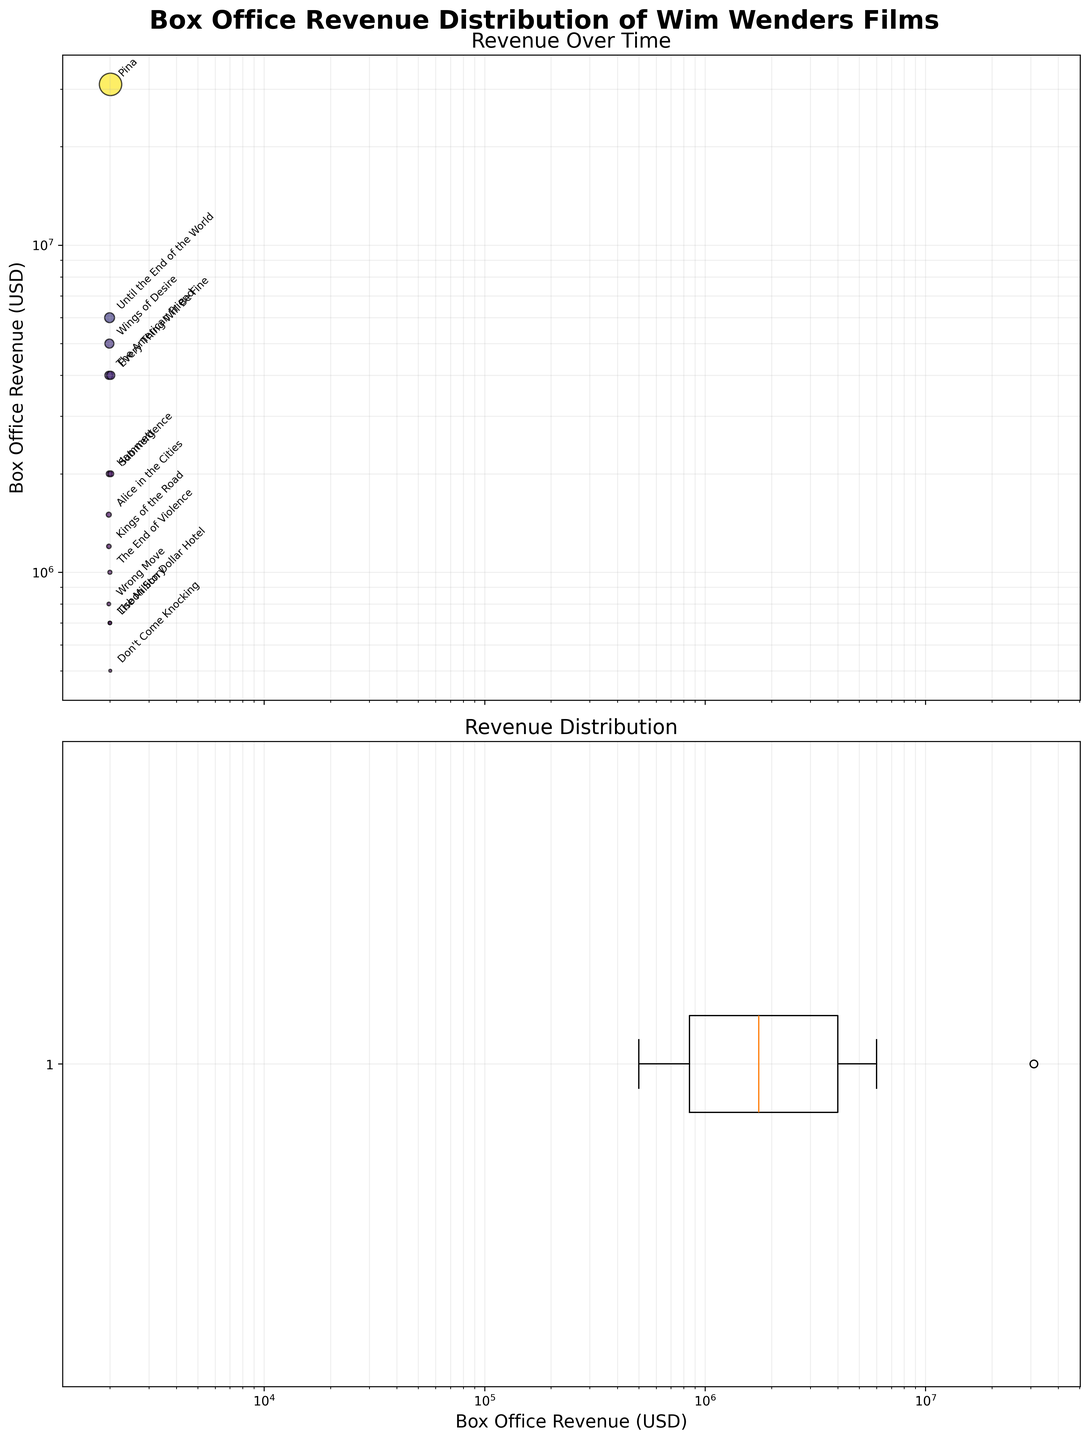What is the title of the first subplot? The title of the first subplot can be found above the plot area. It is usually a short text that summarizes what the subplot represents.
Answer: Revenue Over Time How many films are included in the dataset? By counting the number of data points (or scatter points) visible in the first subplot, we can determine the number of films. Additionally, each data point represents a different film, and their names are annotated on the plot.
Answer: 14 Which film has the highest box office revenue? The film with the highest box office revenue can be identified in the scatter plot where the y-axis value is at its maximum. Here, "Pina" stands out at the top of the plot. Moreover, the log scale on the y-axis helps visualize it clearly.
Answer: Pina What is the approximate box office revenue range covered in the dataset? Since the y-axis of the first subplot and x-axis of the second are in log scale, we should look at the minimum and maximum values on these axes. The revenues range approximately from ~500,000 to ~31,000,000 USD.
Answer: ~500,000 to ~31,000,000 USD How do the revenues of "The American Friend" and "Every Thing Will Be Fine" compare? Locate "The American Friend" and "Every Thing Will Be Fine" in the first subplot by identifying their respective points and comparing their y-axis values. "The American Friend" is around 4,000,000 USD, while "Every Thing Will Be Fine" is the same.
Answer: They are equal at 4,000,000 USD In which year did Wim Wenders release the film "Kings of the Road"? Find the annotation for "Kings of the Road" and then look at its corresponding x-axis value in the first subplot, which shows the release year.
Answer: 1976 Which film had the least box office revenue and what is that value? In the first subplot, identify the film at the lowermost point of the y-axis. Additionally, in the second subplot, the minimum value in the boxplot represents this revenue. The annotation for "Don't Come Knocking" refers to this film.
Answer: Don't Come Knocking at 500,000 USD How many films had a box office revenue of over 10 million USD? To find this, look at the scatter points in the first subplot that are above the 10 million USD mark on the log scale y-axis. Only Pina fits this criterion.
Answer: 1 film What is the median box office revenue of the films? The median value is represented by the horizontal line within the box in the second subplot. This value is located in the middle of the box representing the distribution.
Answer: Around 1,500,000 USD 